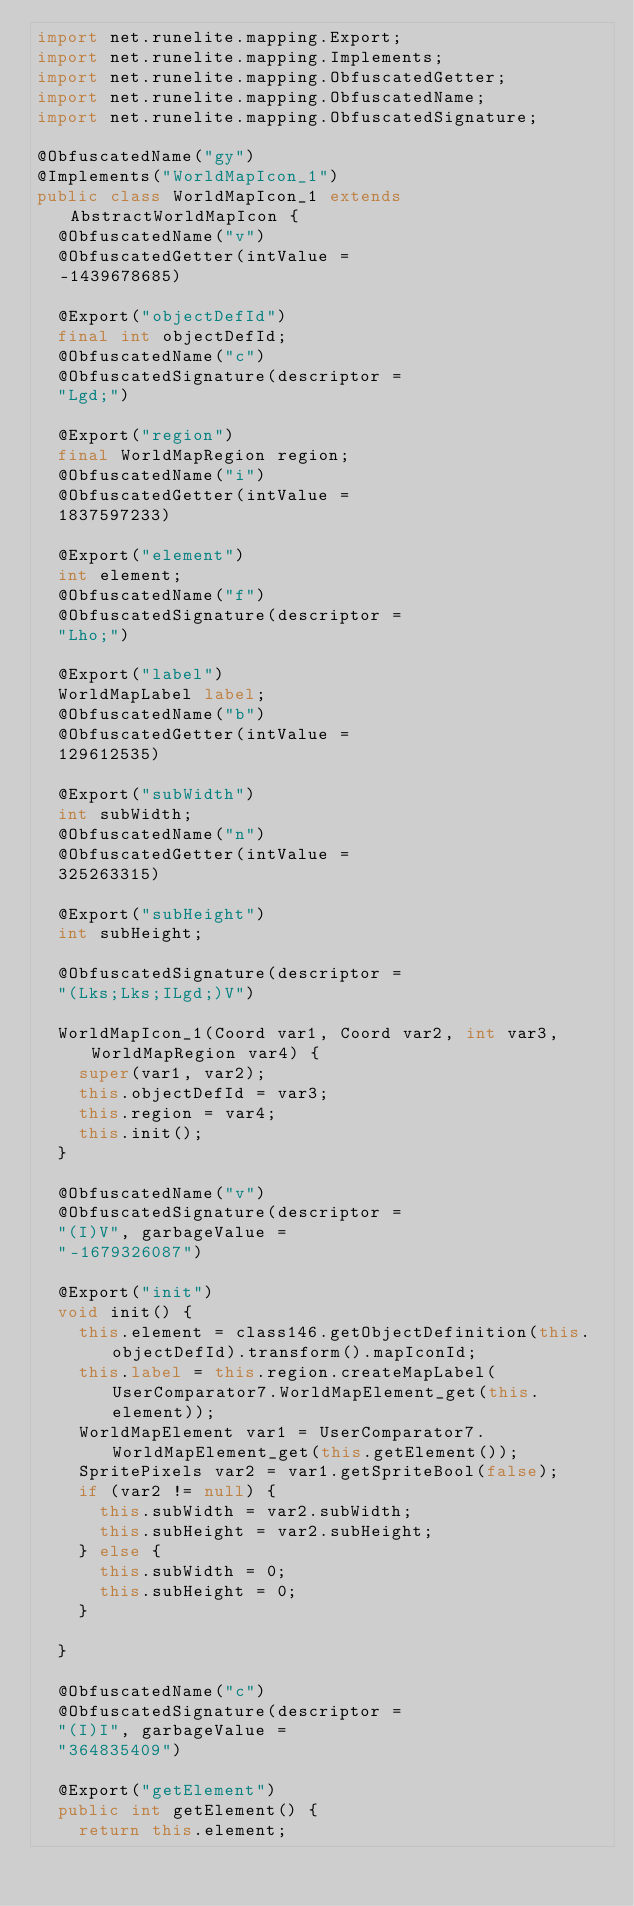Convert code to text. <code><loc_0><loc_0><loc_500><loc_500><_Java_>import net.runelite.mapping.Export;
import net.runelite.mapping.Implements;
import net.runelite.mapping.ObfuscatedGetter;
import net.runelite.mapping.ObfuscatedName;
import net.runelite.mapping.ObfuscatedSignature;

@ObfuscatedName("gy")
@Implements("WorldMapIcon_1")
public class WorldMapIcon_1 extends AbstractWorldMapIcon {
	@ObfuscatedName("v")
	@ObfuscatedGetter(intValue = 
	-1439678685)

	@Export("objectDefId")
	final int objectDefId;
	@ObfuscatedName("c")
	@ObfuscatedSignature(descriptor = 
	"Lgd;")

	@Export("region")
	final WorldMapRegion region;
	@ObfuscatedName("i")
	@ObfuscatedGetter(intValue = 
	1837597233)

	@Export("element")
	int element;
	@ObfuscatedName("f")
	@ObfuscatedSignature(descriptor = 
	"Lho;")

	@Export("label")
	WorldMapLabel label;
	@ObfuscatedName("b")
	@ObfuscatedGetter(intValue = 
	129612535)

	@Export("subWidth")
	int subWidth;
	@ObfuscatedName("n")
	@ObfuscatedGetter(intValue = 
	325263315)

	@Export("subHeight")
	int subHeight;

	@ObfuscatedSignature(descriptor = 
	"(Lks;Lks;ILgd;)V")

	WorldMapIcon_1(Coord var1, Coord var2, int var3, WorldMapRegion var4) {
		super(var1, var2);
		this.objectDefId = var3;
		this.region = var4;
		this.init();
	}

	@ObfuscatedName("v")
	@ObfuscatedSignature(descriptor = 
	"(I)V", garbageValue = 
	"-1679326087")

	@Export("init")
	void init() {
		this.element = class146.getObjectDefinition(this.objectDefId).transform().mapIconId;
		this.label = this.region.createMapLabel(UserComparator7.WorldMapElement_get(this.element));
		WorldMapElement var1 = UserComparator7.WorldMapElement_get(this.getElement());
		SpritePixels var2 = var1.getSpriteBool(false);
		if (var2 != null) {
			this.subWidth = var2.subWidth;
			this.subHeight = var2.subHeight;
		} else {
			this.subWidth = 0;
			this.subHeight = 0;
		}

	}

	@ObfuscatedName("c")
	@ObfuscatedSignature(descriptor = 
	"(I)I", garbageValue = 
	"364835409")

	@Export("getElement")
	public int getElement() {
		return this.element;</code> 